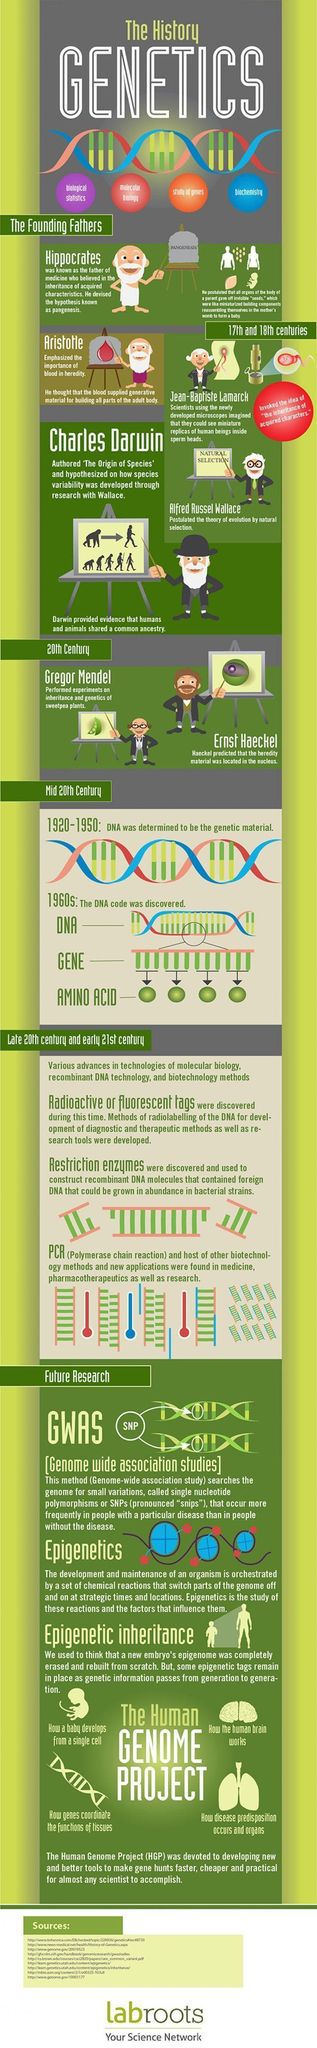When was restriction enzymes discovered
Answer the question with a short phrase. late 20th century and early 21st century What is written on the backrest of thechair Pangenesis Who are the scientist in the 20th century gregor mendel, ernst haeckel Who thought that blood supplied generative material for building all parts of the adult body Aristotle 